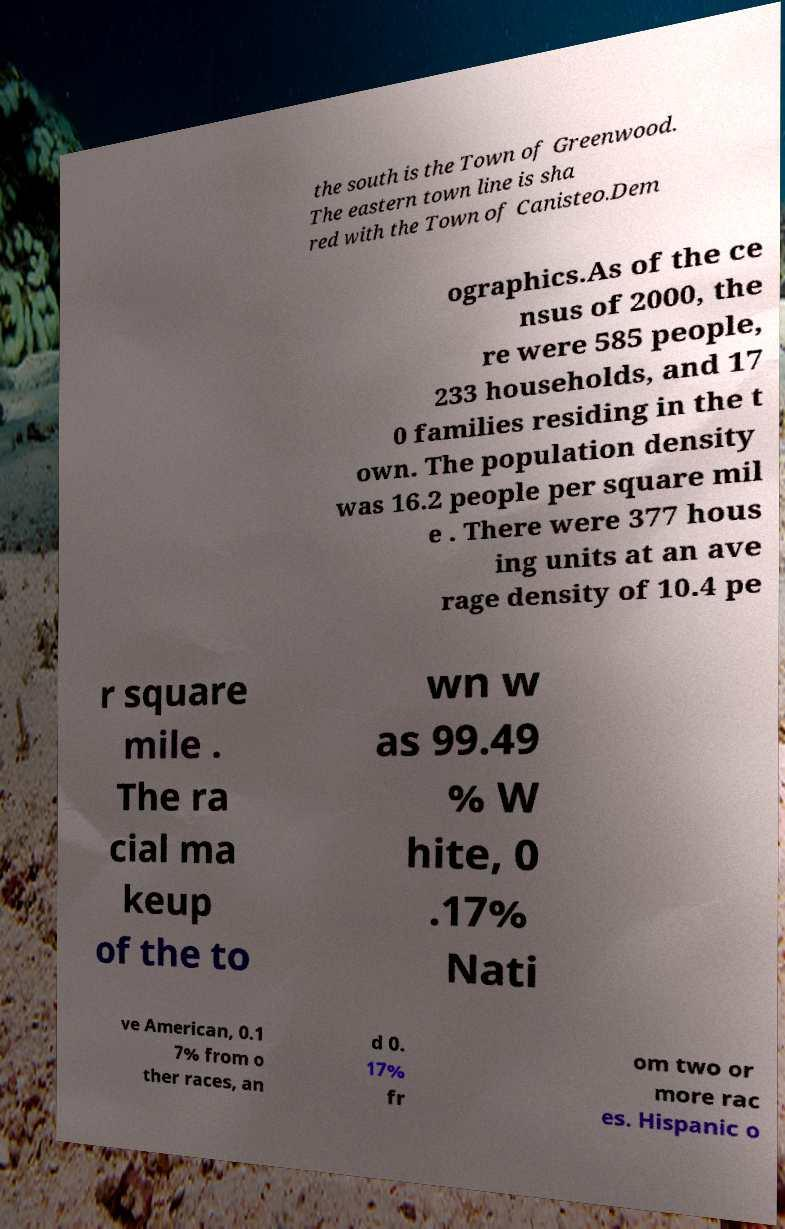Can you read and provide the text displayed in the image?This photo seems to have some interesting text. Can you extract and type it out for me? the south is the Town of Greenwood. The eastern town line is sha red with the Town of Canisteo.Dem ographics.As of the ce nsus of 2000, the re were 585 people, 233 households, and 17 0 families residing in the t own. The population density was 16.2 people per square mil e . There were 377 hous ing units at an ave rage density of 10.4 pe r square mile . The ra cial ma keup of the to wn w as 99.49 % W hite, 0 .17% Nati ve American, 0.1 7% from o ther races, an d 0. 17% fr om two or more rac es. Hispanic o 